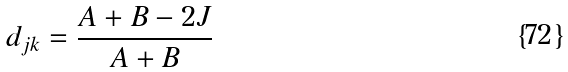<formula> <loc_0><loc_0><loc_500><loc_500>d _ { j k } = \frac { A + B - 2 J } { A + B }</formula> 